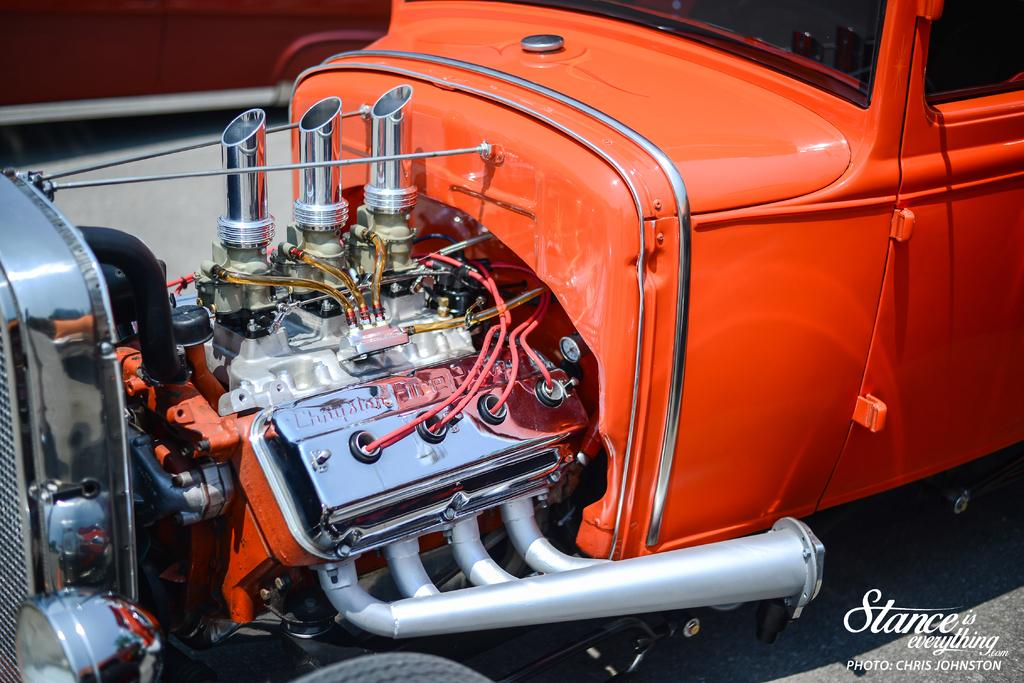What type of vehicle is on the ground in the image? There is a vehicle on the ground in the image, and it has an engine. Can you describe anything in the background of the image? There is an object in the background of the image. Where is the text located in the image? The text is visible in the bottom right corner of the image. How many bees can be seen flying around the vehicle in the image? There are no bees visible in the image; it only features a vehicle on the ground and an object in the background. 